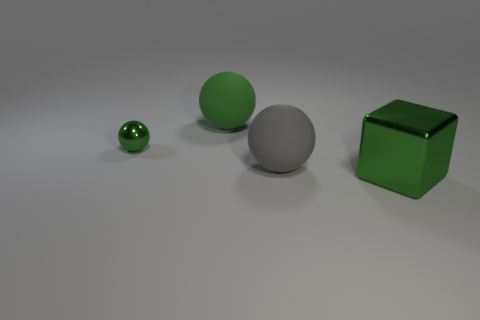Add 1 cyan shiny cylinders. How many objects exist? 5 Subtract all cubes. How many objects are left? 3 Subtract all big rubber balls. Subtract all metal balls. How many objects are left? 1 Add 1 tiny balls. How many tiny balls are left? 2 Add 4 green metallic things. How many green metallic things exist? 6 Subtract 0 brown balls. How many objects are left? 4 